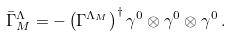Convert formula to latex. <formula><loc_0><loc_0><loc_500><loc_500>\bar { \Gamma } ^ { \Lambda } _ { M } = - \left ( \Gamma ^ { \Lambda _ { M } } \right ) ^ { \dagger } \gamma ^ { 0 } \otimes \gamma ^ { 0 } \otimes \gamma ^ { 0 } \, .</formula> 